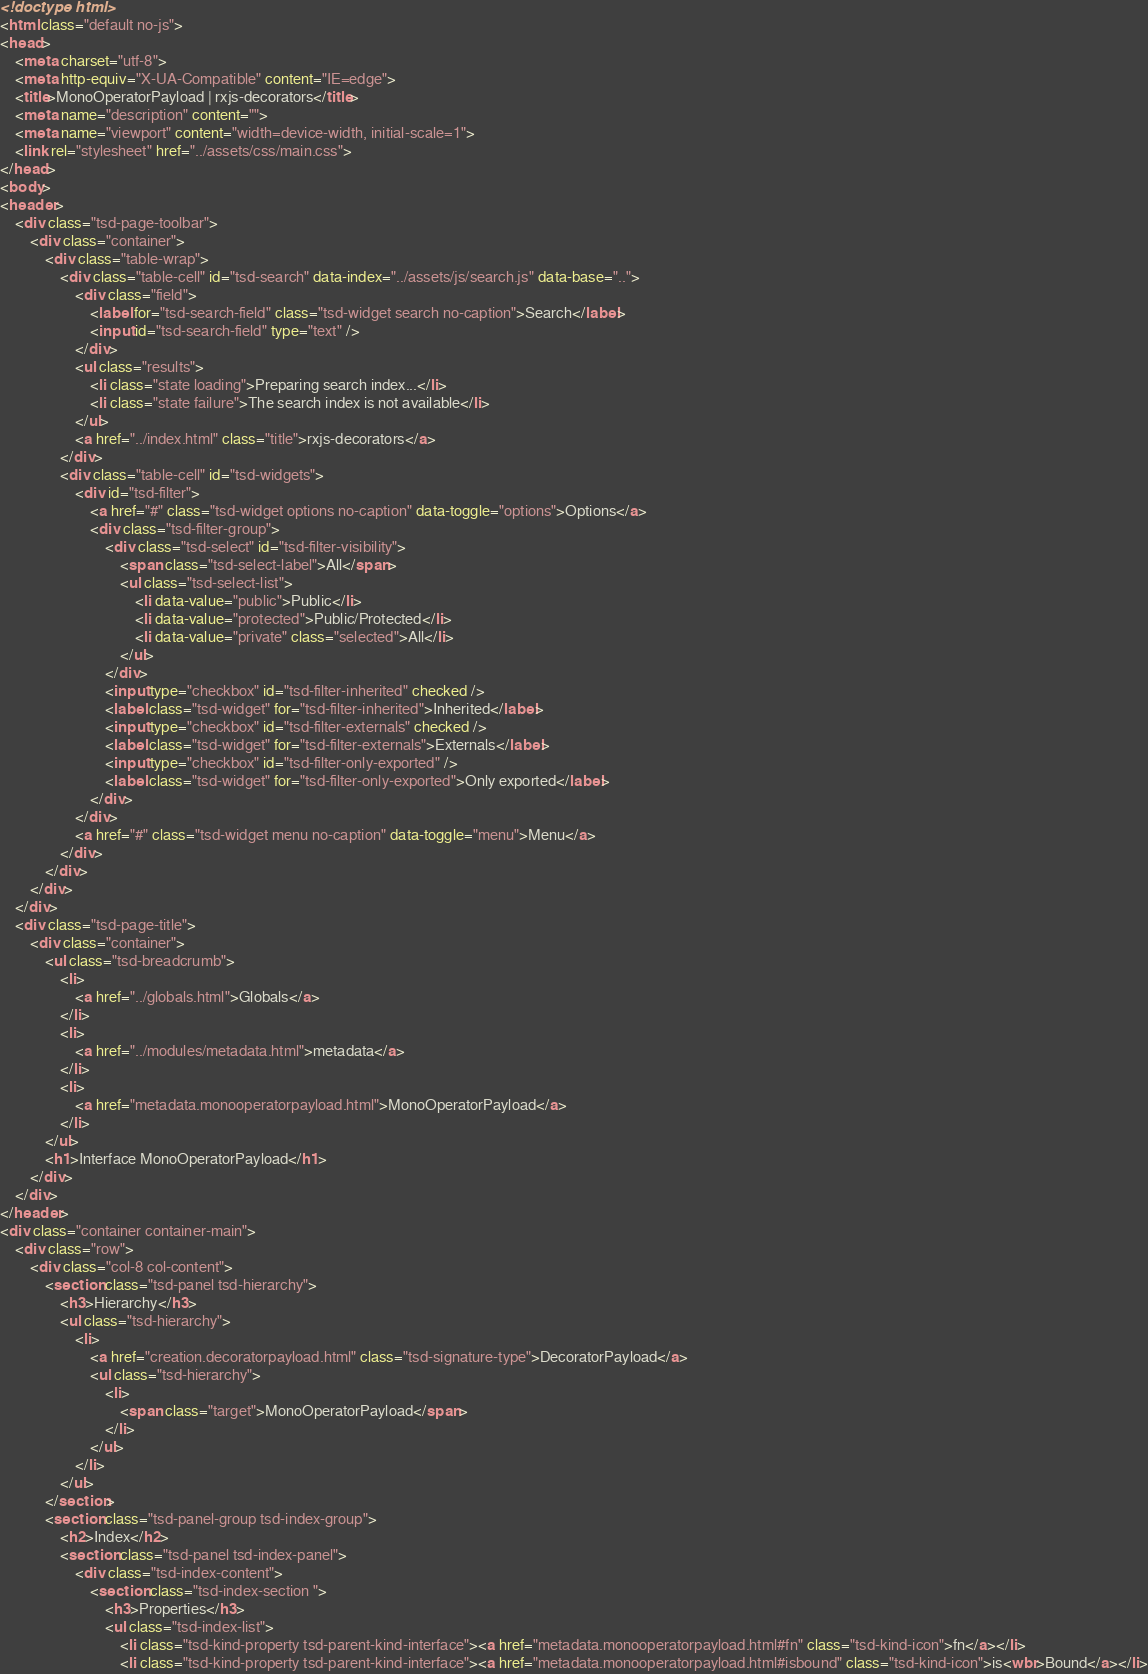Convert code to text. <code><loc_0><loc_0><loc_500><loc_500><_HTML_><!doctype html>
<html class="default no-js">
<head>
	<meta charset="utf-8">
	<meta http-equiv="X-UA-Compatible" content="IE=edge">
	<title>MonoOperatorPayload | rxjs-decorators</title>
	<meta name="description" content="">
	<meta name="viewport" content="width=device-width, initial-scale=1">
	<link rel="stylesheet" href="../assets/css/main.css">
</head>
<body>
<header>
	<div class="tsd-page-toolbar">
		<div class="container">
			<div class="table-wrap">
				<div class="table-cell" id="tsd-search" data-index="../assets/js/search.js" data-base="..">
					<div class="field">
						<label for="tsd-search-field" class="tsd-widget search no-caption">Search</label>
						<input id="tsd-search-field" type="text" />
					</div>
					<ul class="results">
						<li class="state loading">Preparing search index...</li>
						<li class="state failure">The search index is not available</li>
					</ul>
					<a href="../index.html" class="title">rxjs-decorators</a>
				</div>
				<div class="table-cell" id="tsd-widgets">
					<div id="tsd-filter">
						<a href="#" class="tsd-widget options no-caption" data-toggle="options">Options</a>
						<div class="tsd-filter-group">
							<div class="tsd-select" id="tsd-filter-visibility">
								<span class="tsd-select-label">All</span>
								<ul class="tsd-select-list">
									<li data-value="public">Public</li>
									<li data-value="protected">Public/Protected</li>
									<li data-value="private" class="selected">All</li>
								</ul>
							</div>
							<input type="checkbox" id="tsd-filter-inherited" checked />
							<label class="tsd-widget" for="tsd-filter-inherited">Inherited</label>
							<input type="checkbox" id="tsd-filter-externals" checked />
							<label class="tsd-widget" for="tsd-filter-externals">Externals</label>
							<input type="checkbox" id="tsd-filter-only-exported" />
							<label class="tsd-widget" for="tsd-filter-only-exported">Only exported</label>
						</div>
					</div>
					<a href="#" class="tsd-widget menu no-caption" data-toggle="menu">Menu</a>
				</div>
			</div>
		</div>
	</div>
	<div class="tsd-page-title">
		<div class="container">
			<ul class="tsd-breadcrumb">
				<li>
					<a href="../globals.html">Globals</a>
				</li>
				<li>
					<a href="../modules/metadata.html">metadata</a>
				</li>
				<li>
					<a href="metadata.monooperatorpayload.html">MonoOperatorPayload</a>
				</li>
			</ul>
			<h1>Interface MonoOperatorPayload</h1>
		</div>
	</div>
</header>
<div class="container container-main">
	<div class="row">
		<div class="col-8 col-content">
			<section class="tsd-panel tsd-hierarchy">
				<h3>Hierarchy</h3>
				<ul class="tsd-hierarchy">
					<li>
						<a href="creation.decoratorpayload.html" class="tsd-signature-type">DecoratorPayload</a>
						<ul class="tsd-hierarchy">
							<li>
								<span class="target">MonoOperatorPayload</span>
							</li>
						</ul>
					</li>
				</ul>
			</section>
			<section class="tsd-panel-group tsd-index-group">
				<h2>Index</h2>
				<section class="tsd-panel tsd-index-panel">
					<div class="tsd-index-content">
						<section class="tsd-index-section ">
							<h3>Properties</h3>
							<ul class="tsd-index-list">
								<li class="tsd-kind-property tsd-parent-kind-interface"><a href="metadata.monooperatorpayload.html#fn" class="tsd-kind-icon">fn</a></li>
								<li class="tsd-kind-property tsd-parent-kind-interface"><a href="metadata.monooperatorpayload.html#isbound" class="tsd-kind-icon">is<wbr>Bound</a></li></code> 